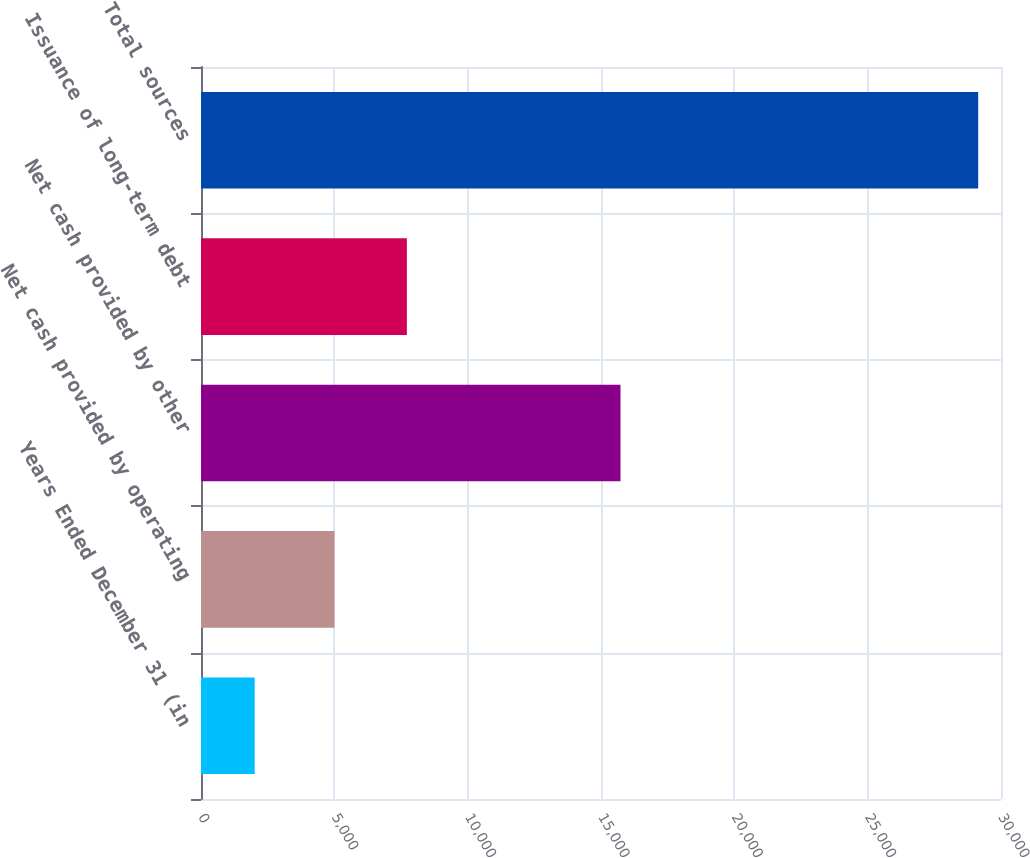<chart> <loc_0><loc_0><loc_500><loc_500><bar_chart><fcel>Years Ended December 31 (in<fcel>Net cash provided by operating<fcel>Net cash provided by other<fcel>Issuance of long-term debt<fcel>Total sources<nl><fcel>2014<fcel>5007<fcel>15731<fcel>7720<fcel>29144<nl></chart> 